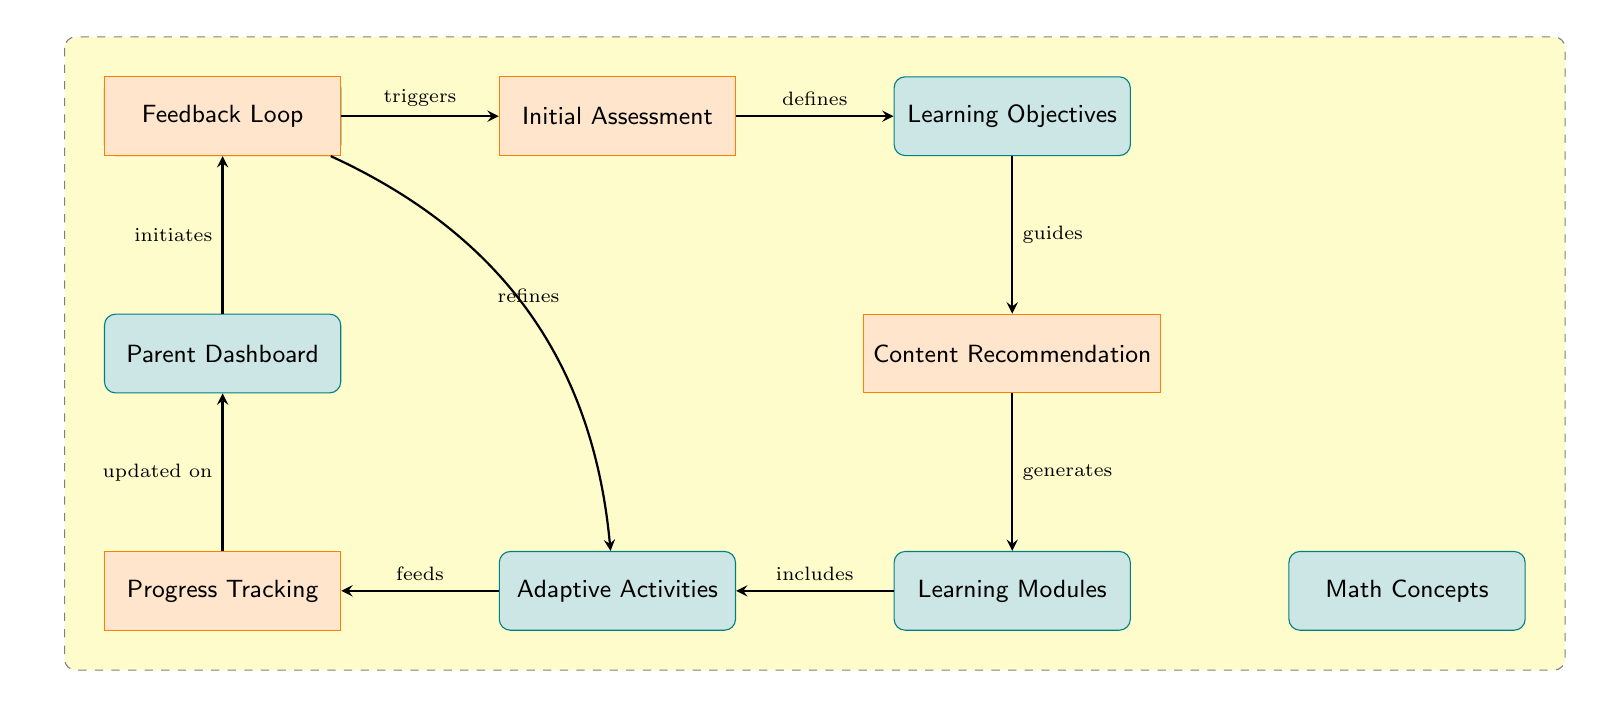What is the first step after the Student Profile? The first step after the Student Profile is the Initial Assessment, which is triggered by the student profile.
Answer: Initial Assessment How many data nodes are in the diagram? The data nodes in the diagram are Student Profile, Learning Objectives, Learning Modules, Adaptive Activities, Parent Dashboard, and Math Concepts, totaling six data nodes.
Answer: 6 What does the Feedback Loop refine? The Feedback Loop refines Adaptive Activities, as indicated by the arrow pointing from the Feedback Loop to Adaptive Activities labeled 'refines'.
Answer: Adaptive Activities What action is generated from the Content Recommendation? The action generated from the Content Recommendation is the Learning Modules, as shown by the arrow pointing to the Learning Modules labeled 'generates'.
Answer: Learning Modules What is updated on the Parent Dashboard? The Parent Dashboard is updated on Progress Tracking, as indicated by the arrow from Progress Tracking to Parent Dashboard labeled 'updated on'.
Answer: Progress Tracking How does the Learning Objectives influence the Content Recommendation? The Learning Objectives guide the Content Recommendation, as shown by the arrow between Learning Objectives and Content Recommendation labeled 'guides'.
Answer: guides What type of activities are included with Learning Modules? Adaptive Activities are included with Learning Modules, as indicated by the arrow directed towards Adaptive Activities labeled 'includes'.
Answer: Adaptive Activities What node initiates the Feedback Loop? The node that initiates the Feedback Loop is the Parent Dashboard, which has an arrow pointing to Feedback Loop labeled 'initiates'.
Answer: Parent Dashboard How do Adaptive Activities affect Progress Tracking? Adaptive Activities feed into Progress Tracking, as shown by the arrow pointing from Adaptive Activities to Progress Tracking labeled 'feeds'.
Answer: feeds 